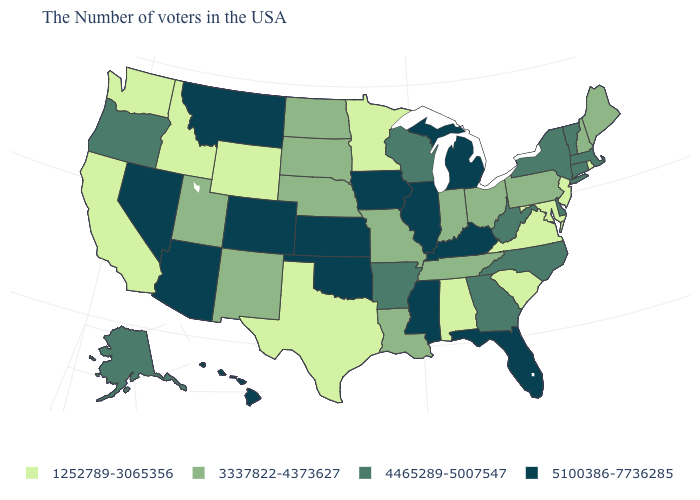Name the states that have a value in the range 3337822-4373627?
Quick response, please. Maine, New Hampshire, Pennsylvania, Ohio, Indiana, Tennessee, Louisiana, Missouri, Nebraska, South Dakota, North Dakota, New Mexico, Utah. What is the lowest value in the USA?
Short answer required. 1252789-3065356. Name the states that have a value in the range 1252789-3065356?
Write a very short answer. Rhode Island, New Jersey, Maryland, Virginia, South Carolina, Alabama, Minnesota, Texas, Wyoming, Idaho, California, Washington. Which states have the lowest value in the USA?
Write a very short answer. Rhode Island, New Jersey, Maryland, Virginia, South Carolina, Alabama, Minnesota, Texas, Wyoming, Idaho, California, Washington. What is the value of Montana?
Give a very brief answer. 5100386-7736285. How many symbols are there in the legend?
Write a very short answer. 4. What is the lowest value in the USA?
Give a very brief answer. 1252789-3065356. Name the states that have a value in the range 5100386-7736285?
Write a very short answer. Florida, Michigan, Kentucky, Illinois, Mississippi, Iowa, Kansas, Oklahoma, Colorado, Montana, Arizona, Nevada, Hawaii. What is the lowest value in states that border Kentucky?
Quick response, please. 1252789-3065356. What is the lowest value in the MidWest?
Give a very brief answer. 1252789-3065356. What is the lowest value in the MidWest?
Keep it brief. 1252789-3065356. Name the states that have a value in the range 5100386-7736285?
Give a very brief answer. Florida, Michigan, Kentucky, Illinois, Mississippi, Iowa, Kansas, Oklahoma, Colorado, Montana, Arizona, Nevada, Hawaii. Name the states that have a value in the range 4465289-5007547?
Short answer required. Massachusetts, Vermont, Connecticut, New York, Delaware, North Carolina, West Virginia, Georgia, Wisconsin, Arkansas, Oregon, Alaska. Name the states that have a value in the range 3337822-4373627?
Quick response, please. Maine, New Hampshire, Pennsylvania, Ohio, Indiana, Tennessee, Louisiana, Missouri, Nebraska, South Dakota, North Dakota, New Mexico, Utah. What is the lowest value in the USA?
Give a very brief answer. 1252789-3065356. 